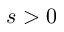<formula> <loc_0><loc_0><loc_500><loc_500>s > 0</formula> 